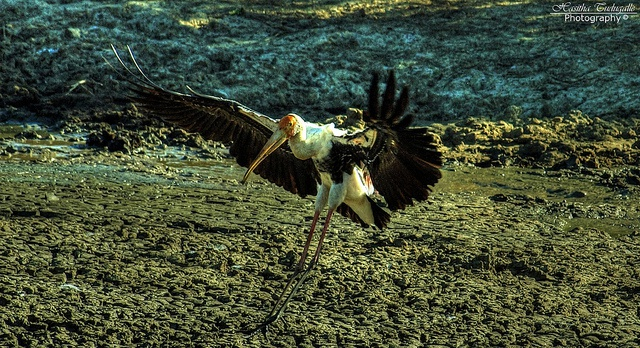Describe the objects in this image and their specific colors. I can see a bird in teal, black, darkgreen, gray, and olive tones in this image. 